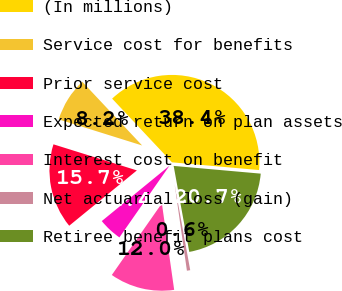Convert chart. <chart><loc_0><loc_0><loc_500><loc_500><pie_chart><fcel>(In millions)<fcel>Service cost for benefits<fcel>Prior service cost<fcel>Expected return on plan assets<fcel>Interest cost on benefit<fcel>Net actuarial loss (gain)<fcel>Retiree benefit plans cost<nl><fcel>38.41%<fcel>8.17%<fcel>15.73%<fcel>4.39%<fcel>11.95%<fcel>0.61%<fcel>20.73%<nl></chart> 